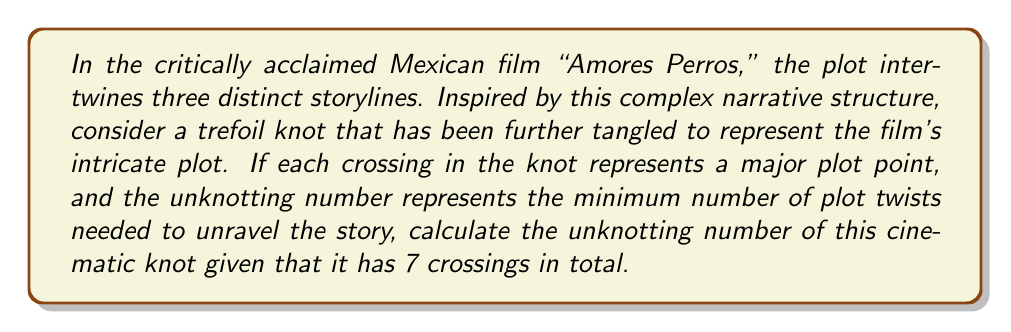Solve this math problem. To solve this problem, we need to follow these steps:

1. Recall that a trefoil knot has 3 crossings and an unknotting number of 1.

2. The given knot has 7 crossings, which means it has 4 additional crossings compared to a standard trefoil knot.

3. In knot theory, the unknotting number $u(K)$ of a knot $K$ satisfies the inequality:

   $$u(K) \leq \frac{c(K) - 1}{2}$$

   where $c(K)$ is the crossing number of the knot.

4. For our cinematic knot:
   $$u(K) \leq \frac{7 - 1}{2} = 3$$

5. However, we know that the trefoil knot (with 3 crossings) already has an unknotting number of 1. Each additional crossing can increase the unknotting number by at most 1.

6. Therefore, the unknotting number of our cinematic knot is:

   $$u(K) = 1 + (7 - 3) = 1 + 4 = 5$$

This means that a minimum of 5 plot twists would be needed to unravel the complex narrative structure of this hypothetical film inspired by "Amores Perros."
Answer: 5 